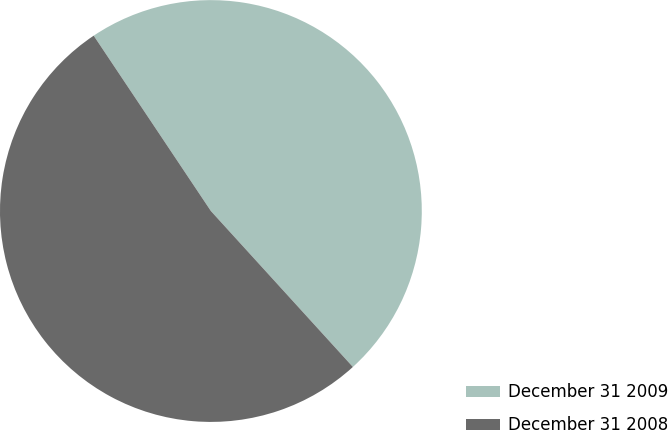Convert chart. <chart><loc_0><loc_0><loc_500><loc_500><pie_chart><fcel>December 31 2009<fcel>December 31 2008<nl><fcel>47.62%<fcel>52.38%<nl></chart> 